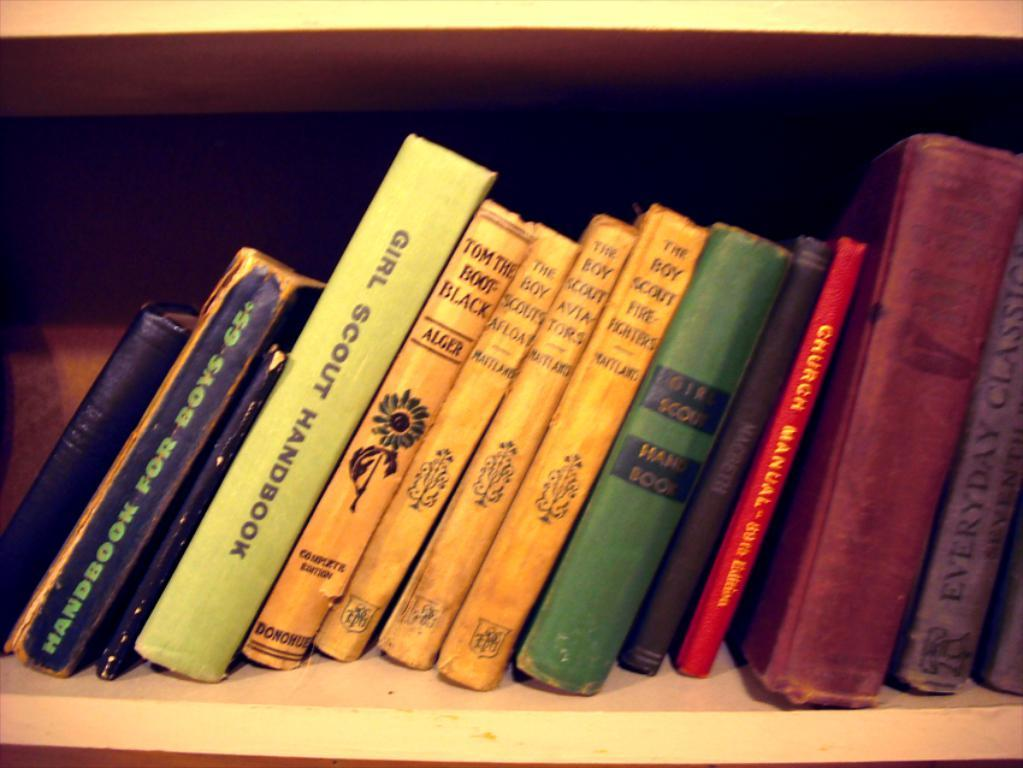<image>
Provide a brief description of the given image. A wooden shelf with books on it and one of them is called Girl Scout Handbook. 